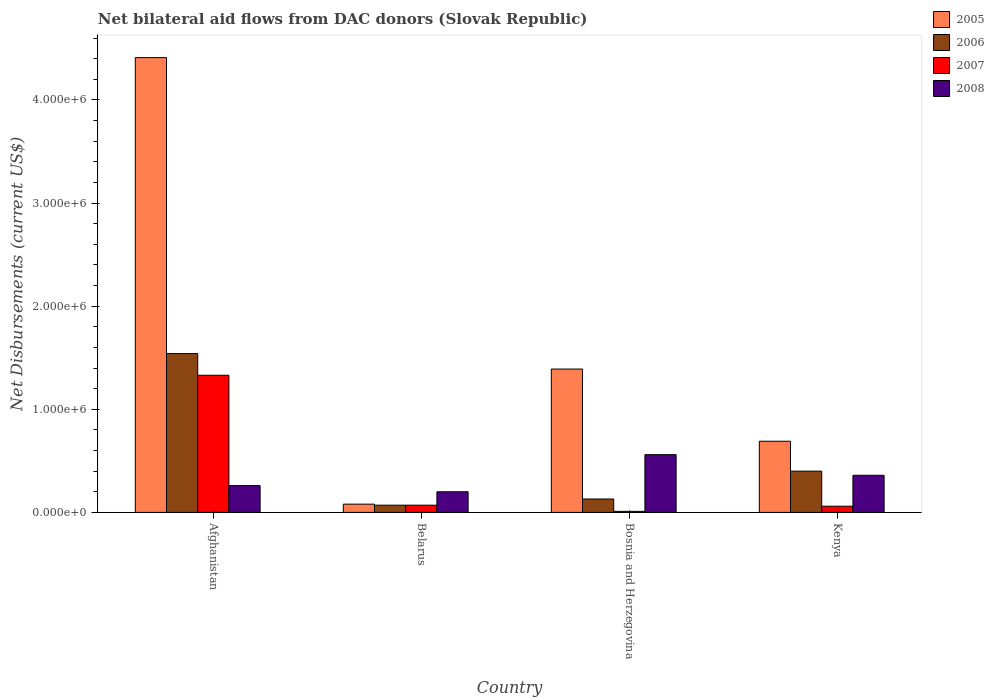How many different coloured bars are there?
Make the answer very short. 4. Are the number of bars on each tick of the X-axis equal?
Provide a succinct answer. Yes. What is the label of the 1st group of bars from the left?
Ensure brevity in your answer.  Afghanistan. What is the net bilateral aid flows in 2005 in Afghanistan?
Your response must be concise. 4.41e+06. Across all countries, what is the maximum net bilateral aid flows in 2006?
Ensure brevity in your answer.  1.54e+06. In which country was the net bilateral aid flows in 2007 maximum?
Provide a short and direct response. Afghanistan. In which country was the net bilateral aid flows in 2006 minimum?
Provide a succinct answer. Belarus. What is the total net bilateral aid flows in 2008 in the graph?
Provide a short and direct response. 1.38e+06. What is the difference between the net bilateral aid flows in 2008 in Bosnia and Herzegovina and the net bilateral aid flows in 2005 in Afghanistan?
Make the answer very short. -3.85e+06. What is the average net bilateral aid flows in 2007 per country?
Your response must be concise. 3.68e+05. In how many countries, is the net bilateral aid flows in 2007 greater than 3600000 US$?
Your response must be concise. 0. What is the ratio of the net bilateral aid flows in 2006 in Afghanistan to that in Kenya?
Provide a short and direct response. 3.85. Is the net bilateral aid flows in 2005 in Afghanistan less than that in Bosnia and Herzegovina?
Your answer should be compact. No. Is the difference between the net bilateral aid flows in 2007 in Belarus and Kenya greater than the difference between the net bilateral aid flows in 2008 in Belarus and Kenya?
Provide a succinct answer. Yes. What is the difference between the highest and the second highest net bilateral aid flows in 2007?
Your answer should be compact. 1.26e+06. In how many countries, is the net bilateral aid flows in 2007 greater than the average net bilateral aid flows in 2007 taken over all countries?
Your answer should be very brief. 1. Is the sum of the net bilateral aid flows in 2005 in Afghanistan and Bosnia and Herzegovina greater than the maximum net bilateral aid flows in 2007 across all countries?
Offer a very short reply. Yes. What does the 1st bar from the left in Belarus represents?
Your answer should be very brief. 2005. What does the 1st bar from the right in Afghanistan represents?
Provide a short and direct response. 2008. Are all the bars in the graph horizontal?
Keep it short and to the point. No. How many countries are there in the graph?
Give a very brief answer. 4. What is the difference between two consecutive major ticks on the Y-axis?
Give a very brief answer. 1.00e+06. How many legend labels are there?
Your response must be concise. 4. How are the legend labels stacked?
Provide a short and direct response. Vertical. What is the title of the graph?
Offer a terse response. Net bilateral aid flows from DAC donors (Slovak Republic). What is the label or title of the X-axis?
Make the answer very short. Country. What is the label or title of the Y-axis?
Ensure brevity in your answer.  Net Disbursements (current US$). What is the Net Disbursements (current US$) of 2005 in Afghanistan?
Your answer should be compact. 4.41e+06. What is the Net Disbursements (current US$) in 2006 in Afghanistan?
Your response must be concise. 1.54e+06. What is the Net Disbursements (current US$) of 2007 in Afghanistan?
Make the answer very short. 1.33e+06. What is the Net Disbursements (current US$) in 2006 in Belarus?
Ensure brevity in your answer.  7.00e+04. What is the Net Disbursements (current US$) in 2007 in Belarus?
Keep it short and to the point. 7.00e+04. What is the Net Disbursements (current US$) of 2005 in Bosnia and Herzegovina?
Provide a succinct answer. 1.39e+06. What is the Net Disbursements (current US$) of 2006 in Bosnia and Herzegovina?
Provide a succinct answer. 1.30e+05. What is the Net Disbursements (current US$) of 2007 in Bosnia and Herzegovina?
Offer a very short reply. 10000. What is the Net Disbursements (current US$) in 2008 in Bosnia and Herzegovina?
Offer a terse response. 5.60e+05. What is the Net Disbursements (current US$) of 2005 in Kenya?
Provide a short and direct response. 6.90e+05. What is the Net Disbursements (current US$) of 2007 in Kenya?
Provide a succinct answer. 6.00e+04. What is the Net Disbursements (current US$) in 2008 in Kenya?
Offer a very short reply. 3.60e+05. Across all countries, what is the maximum Net Disbursements (current US$) of 2005?
Keep it short and to the point. 4.41e+06. Across all countries, what is the maximum Net Disbursements (current US$) in 2006?
Ensure brevity in your answer.  1.54e+06. Across all countries, what is the maximum Net Disbursements (current US$) in 2007?
Your response must be concise. 1.33e+06. Across all countries, what is the maximum Net Disbursements (current US$) in 2008?
Your answer should be compact. 5.60e+05. Across all countries, what is the minimum Net Disbursements (current US$) of 2006?
Offer a very short reply. 7.00e+04. Across all countries, what is the minimum Net Disbursements (current US$) of 2008?
Make the answer very short. 2.00e+05. What is the total Net Disbursements (current US$) of 2005 in the graph?
Your answer should be compact. 6.57e+06. What is the total Net Disbursements (current US$) of 2006 in the graph?
Ensure brevity in your answer.  2.14e+06. What is the total Net Disbursements (current US$) of 2007 in the graph?
Make the answer very short. 1.47e+06. What is the total Net Disbursements (current US$) in 2008 in the graph?
Your answer should be very brief. 1.38e+06. What is the difference between the Net Disbursements (current US$) of 2005 in Afghanistan and that in Belarus?
Keep it short and to the point. 4.33e+06. What is the difference between the Net Disbursements (current US$) in 2006 in Afghanistan and that in Belarus?
Your answer should be very brief. 1.47e+06. What is the difference between the Net Disbursements (current US$) in 2007 in Afghanistan and that in Belarus?
Provide a short and direct response. 1.26e+06. What is the difference between the Net Disbursements (current US$) of 2005 in Afghanistan and that in Bosnia and Herzegovina?
Provide a short and direct response. 3.02e+06. What is the difference between the Net Disbursements (current US$) of 2006 in Afghanistan and that in Bosnia and Herzegovina?
Your answer should be compact. 1.41e+06. What is the difference between the Net Disbursements (current US$) in 2007 in Afghanistan and that in Bosnia and Herzegovina?
Your response must be concise. 1.32e+06. What is the difference between the Net Disbursements (current US$) of 2005 in Afghanistan and that in Kenya?
Offer a terse response. 3.72e+06. What is the difference between the Net Disbursements (current US$) of 2006 in Afghanistan and that in Kenya?
Offer a terse response. 1.14e+06. What is the difference between the Net Disbursements (current US$) in 2007 in Afghanistan and that in Kenya?
Offer a terse response. 1.27e+06. What is the difference between the Net Disbursements (current US$) in 2008 in Afghanistan and that in Kenya?
Your response must be concise. -1.00e+05. What is the difference between the Net Disbursements (current US$) of 2005 in Belarus and that in Bosnia and Herzegovina?
Make the answer very short. -1.31e+06. What is the difference between the Net Disbursements (current US$) in 2007 in Belarus and that in Bosnia and Herzegovina?
Provide a short and direct response. 6.00e+04. What is the difference between the Net Disbursements (current US$) in 2008 in Belarus and that in Bosnia and Herzegovina?
Offer a very short reply. -3.60e+05. What is the difference between the Net Disbursements (current US$) of 2005 in Belarus and that in Kenya?
Keep it short and to the point. -6.10e+05. What is the difference between the Net Disbursements (current US$) in 2006 in Belarus and that in Kenya?
Your response must be concise. -3.30e+05. What is the difference between the Net Disbursements (current US$) of 2008 in Bosnia and Herzegovina and that in Kenya?
Provide a short and direct response. 2.00e+05. What is the difference between the Net Disbursements (current US$) in 2005 in Afghanistan and the Net Disbursements (current US$) in 2006 in Belarus?
Your answer should be very brief. 4.34e+06. What is the difference between the Net Disbursements (current US$) in 2005 in Afghanistan and the Net Disbursements (current US$) in 2007 in Belarus?
Provide a succinct answer. 4.34e+06. What is the difference between the Net Disbursements (current US$) of 2005 in Afghanistan and the Net Disbursements (current US$) of 2008 in Belarus?
Offer a very short reply. 4.21e+06. What is the difference between the Net Disbursements (current US$) in 2006 in Afghanistan and the Net Disbursements (current US$) in 2007 in Belarus?
Your response must be concise. 1.47e+06. What is the difference between the Net Disbursements (current US$) in 2006 in Afghanistan and the Net Disbursements (current US$) in 2008 in Belarus?
Offer a terse response. 1.34e+06. What is the difference between the Net Disbursements (current US$) of 2007 in Afghanistan and the Net Disbursements (current US$) of 2008 in Belarus?
Provide a succinct answer. 1.13e+06. What is the difference between the Net Disbursements (current US$) of 2005 in Afghanistan and the Net Disbursements (current US$) of 2006 in Bosnia and Herzegovina?
Offer a very short reply. 4.28e+06. What is the difference between the Net Disbursements (current US$) in 2005 in Afghanistan and the Net Disbursements (current US$) in 2007 in Bosnia and Herzegovina?
Your response must be concise. 4.40e+06. What is the difference between the Net Disbursements (current US$) in 2005 in Afghanistan and the Net Disbursements (current US$) in 2008 in Bosnia and Herzegovina?
Offer a very short reply. 3.85e+06. What is the difference between the Net Disbursements (current US$) in 2006 in Afghanistan and the Net Disbursements (current US$) in 2007 in Bosnia and Herzegovina?
Your answer should be compact. 1.53e+06. What is the difference between the Net Disbursements (current US$) in 2006 in Afghanistan and the Net Disbursements (current US$) in 2008 in Bosnia and Herzegovina?
Provide a short and direct response. 9.80e+05. What is the difference between the Net Disbursements (current US$) of 2007 in Afghanistan and the Net Disbursements (current US$) of 2008 in Bosnia and Herzegovina?
Give a very brief answer. 7.70e+05. What is the difference between the Net Disbursements (current US$) in 2005 in Afghanistan and the Net Disbursements (current US$) in 2006 in Kenya?
Give a very brief answer. 4.01e+06. What is the difference between the Net Disbursements (current US$) of 2005 in Afghanistan and the Net Disbursements (current US$) of 2007 in Kenya?
Your answer should be very brief. 4.35e+06. What is the difference between the Net Disbursements (current US$) in 2005 in Afghanistan and the Net Disbursements (current US$) in 2008 in Kenya?
Your response must be concise. 4.05e+06. What is the difference between the Net Disbursements (current US$) of 2006 in Afghanistan and the Net Disbursements (current US$) of 2007 in Kenya?
Make the answer very short. 1.48e+06. What is the difference between the Net Disbursements (current US$) in 2006 in Afghanistan and the Net Disbursements (current US$) in 2008 in Kenya?
Your answer should be compact. 1.18e+06. What is the difference between the Net Disbursements (current US$) of 2007 in Afghanistan and the Net Disbursements (current US$) of 2008 in Kenya?
Ensure brevity in your answer.  9.70e+05. What is the difference between the Net Disbursements (current US$) in 2005 in Belarus and the Net Disbursements (current US$) in 2006 in Bosnia and Herzegovina?
Provide a succinct answer. -5.00e+04. What is the difference between the Net Disbursements (current US$) of 2005 in Belarus and the Net Disbursements (current US$) of 2007 in Bosnia and Herzegovina?
Give a very brief answer. 7.00e+04. What is the difference between the Net Disbursements (current US$) of 2005 in Belarus and the Net Disbursements (current US$) of 2008 in Bosnia and Herzegovina?
Offer a very short reply. -4.80e+05. What is the difference between the Net Disbursements (current US$) in 2006 in Belarus and the Net Disbursements (current US$) in 2008 in Bosnia and Herzegovina?
Provide a short and direct response. -4.90e+05. What is the difference between the Net Disbursements (current US$) of 2007 in Belarus and the Net Disbursements (current US$) of 2008 in Bosnia and Herzegovina?
Ensure brevity in your answer.  -4.90e+05. What is the difference between the Net Disbursements (current US$) of 2005 in Belarus and the Net Disbursements (current US$) of 2006 in Kenya?
Make the answer very short. -3.20e+05. What is the difference between the Net Disbursements (current US$) in 2005 in Belarus and the Net Disbursements (current US$) in 2007 in Kenya?
Your response must be concise. 2.00e+04. What is the difference between the Net Disbursements (current US$) in 2005 in Belarus and the Net Disbursements (current US$) in 2008 in Kenya?
Ensure brevity in your answer.  -2.80e+05. What is the difference between the Net Disbursements (current US$) in 2006 in Belarus and the Net Disbursements (current US$) in 2007 in Kenya?
Ensure brevity in your answer.  10000. What is the difference between the Net Disbursements (current US$) in 2006 in Belarus and the Net Disbursements (current US$) in 2008 in Kenya?
Make the answer very short. -2.90e+05. What is the difference between the Net Disbursements (current US$) of 2005 in Bosnia and Herzegovina and the Net Disbursements (current US$) of 2006 in Kenya?
Your answer should be compact. 9.90e+05. What is the difference between the Net Disbursements (current US$) in 2005 in Bosnia and Herzegovina and the Net Disbursements (current US$) in 2007 in Kenya?
Offer a very short reply. 1.33e+06. What is the difference between the Net Disbursements (current US$) of 2005 in Bosnia and Herzegovina and the Net Disbursements (current US$) of 2008 in Kenya?
Your response must be concise. 1.03e+06. What is the difference between the Net Disbursements (current US$) in 2006 in Bosnia and Herzegovina and the Net Disbursements (current US$) in 2007 in Kenya?
Your answer should be very brief. 7.00e+04. What is the difference between the Net Disbursements (current US$) in 2007 in Bosnia and Herzegovina and the Net Disbursements (current US$) in 2008 in Kenya?
Provide a succinct answer. -3.50e+05. What is the average Net Disbursements (current US$) of 2005 per country?
Offer a very short reply. 1.64e+06. What is the average Net Disbursements (current US$) in 2006 per country?
Ensure brevity in your answer.  5.35e+05. What is the average Net Disbursements (current US$) in 2007 per country?
Offer a terse response. 3.68e+05. What is the average Net Disbursements (current US$) of 2008 per country?
Give a very brief answer. 3.45e+05. What is the difference between the Net Disbursements (current US$) in 2005 and Net Disbursements (current US$) in 2006 in Afghanistan?
Give a very brief answer. 2.87e+06. What is the difference between the Net Disbursements (current US$) of 2005 and Net Disbursements (current US$) of 2007 in Afghanistan?
Give a very brief answer. 3.08e+06. What is the difference between the Net Disbursements (current US$) in 2005 and Net Disbursements (current US$) in 2008 in Afghanistan?
Your answer should be very brief. 4.15e+06. What is the difference between the Net Disbursements (current US$) of 2006 and Net Disbursements (current US$) of 2008 in Afghanistan?
Keep it short and to the point. 1.28e+06. What is the difference between the Net Disbursements (current US$) of 2007 and Net Disbursements (current US$) of 2008 in Afghanistan?
Ensure brevity in your answer.  1.07e+06. What is the difference between the Net Disbursements (current US$) of 2005 and Net Disbursements (current US$) of 2006 in Belarus?
Ensure brevity in your answer.  10000. What is the difference between the Net Disbursements (current US$) in 2005 and Net Disbursements (current US$) in 2008 in Belarus?
Make the answer very short. -1.20e+05. What is the difference between the Net Disbursements (current US$) of 2006 and Net Disbursements (current US$) of 2008 in Belarus?
Give a very brief answer. -1.30e+05. What is the difference between the Net Disbursements (current US$) of 2007 and Net Disbursements (current US$) of 2008 in Belarus?
Offer a terse response. -1.30e+05. What is the difference between the Net Disbursements (current US$) of 2005 and Net Disbursements (current US$) of 2006 in Bosnia and Herzegovina?
Provide a succinct answer. 1.26e+06. What is the difference between the Net Disbursements (current US$) in 2005 and Net Disbursements (current US$) in 2007 in Bosnia and Herzegovina?
Your answer should be very brief. 1.38e+06. What is the difference between the Net Disbursements (current US$) in 2005 and Net Disbursements (current US$) in 2008 in Bosnia and Herzegovina?
Your answer should be very brief. 8.30e+05. What is the difference between the Net Disbursements (current US$) of 2006 and Net Disbursements (current US$) of 2008 in Bosnia and Herzegovina?
Your answer should be compact. -4.30e+05. What is the difference between the Net Disbursements (current US$) in 2007 and Net Disbursements (current US$) in 2008 in Bosnia and Herzegovina?
Offer a very short reply. -5.50e+05. What is the difference between the Net Disbursements (current US$) of 2005 and Net Disbursements (current US$) of 2007 in Kenya?
Your response must be concise. 6.30e+05. What is the difference between the Net Disbursements (current US$) in 2005 and Net Disbursements (current US$) in 2008 in Kenya?
Give a very brief answer. 3.30e+05. What is the difference between the Net Disbursements (current US$) of 2006 and Net Disbursements (current US$) of 2008 in Kenya?
Offer a very short reply. 4.00e+04. What is the difference between the Net Disbursements (current US$) of 2007 and Net Disbursements (current US$) of 2008 in Kenya?
Offer a terse response. -3.00e+05. What is the ratio of the Net Disbursements (current US$) in 2005 in Afghanistan to that in Belarus?
Provide a short and direct response. 55.12. What is the ratio of the Net Disbursements (current US$) in 2008 in Afghanistan to that in Belarus?
Offer a very short reply. 1.3. What is the ratio of the Net Disbursements (current US$) of 2005 in Afghanistan to that in Bosnia and Herzegovina?
Provide a succinct answer. 3.17. What is the ratio of the Net Disbursements (current US$) of 2006 in Afghanistan to that in Bosnia and Herzegovina?
Give a very brief answer. 11.85. What is the ratio of the Net Disbursements (current US$) of 2007 in Afghanistan to that in Bosnia and Herzegovina?
Your answer should be very brief. 133. What is the ratio of the Net Disbursements (current US$) of 2008 in Afghanistan to that in Bosnia and Herzegovina?
Ensure brevity in your answer.  0.46. What is the ratio of the Net Disbursements (current US$) in 2005 in Afghanistan to that in Kenya?
Make the answer very short. 6.39. What is the ratio of the Net Disbursements (current US$) in 2006 in Afghanistan to that in Kenya?
Provide a succinct answer. 3.85. What is the ratio of the Net Disbursements (current US$) in 2007 in Afghanistan to that in Kenya?
Keep it short and to the point. 22.17. What is the ratio of the Net Disbursements (current US$) of 2008 in Afghanistan to that in Kenya?
Ensure brevity in your answer.  0.72. What is the ratio of the Net Disbursements (current US$) of 2005 in Belarus to that in Bosnia and Herzegovina?
Provide a short and direct response. 0.06. What is the ratio of the Net Disbursements (current US$) in 2006 in Belarus to that in Bosnia and Herzegovina?
Offer a terse response. 0.54. What is the ratio of the Net Disbursements (current US$) in 2008 in Belarus to that in Bosnia and Herzegovina?
Provide a short and direct response. 0.36. What is the ratio of the Net Disbursements (current US$) in 2005 in Belarus to that in Kenya?
Ensure brevity in your answer.  0.12. What is the ratio of the Net Disbursements (current US$) of 2006 in Belarus to that in Kenya?
Give a very brief answer. 0.17. What is the ratio of the Net Disbursements (current US$) of 2007 in Belarus to that in Kenya?
Your answer should be compact. 1.17. What is the ratio of the Net Disbursements (current US$) of 2008 in Belarus to that in Kenya?
Keep it short and to the point. 0.56. What is the ratio of the Net Disbursements (current US$) of 2005 in Bosnia and Herzegovina to that in Kenya?
Provide a succinct answer. 2.01. What is the ratio of the Net Disbursements (current US$) of 2006 in Bosnia and Herzegovina to that in Kenya?
Give a very brief answer. 0.33. What is the ratio of the Net Disbursements (current US$) in 2007 in Bosnia and Herzegovina to that in Kenya?
Make the answer very short. 0.17. What is the ratio of the Net Disbursements (current US$) in 2008 in Bosnia and Herzegovina to that in Kenya?
Your answer should be compact. 1.56. What is the difference between the highest and the second highest Net Disbursements (current US$) in 2005?
Give a very brief answer. 3.02e+06. What is the difference between the highest and the second highest Net Disbursements (current US$) in 2006?
Make the answer very short. 1.14e+06. What is the difference between the highest and the second highest Net Disbursements (current US$) in 2007?
Your answer should be very brief. 1.26e+06. What is the difference between the highest and the second highest Net Disbursements (current US$) of 2008?
Provide a short and direct response. 2.00e+05. What is the difference between the highest and the lowest Net Disbursements (current US$) in 2005?
Your response must be concise. 4.33e+06. What is the difference between the highest and the lowest Net Disbursements (current US$) in 2006?
Ensure brevity in your answer.  1.47e+06. What is the difference between the highest and the lowest Net Disbursements (current US$) in 2007?
Offer a very short reply. 1.32e+06. What is the difference between the highest and the lowest Net Disbursements (current US$) in 2008?
Provide a short and direct response. 3.60e+05. 